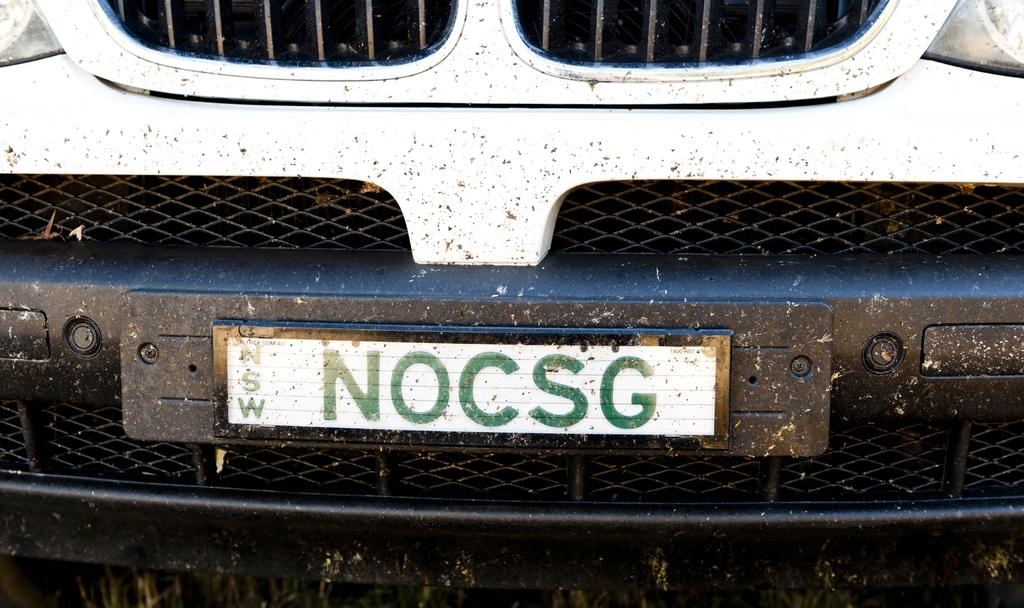Provide a one-sentence caption for the provided image. NOCSG is on a license plate on a white vehicle. 